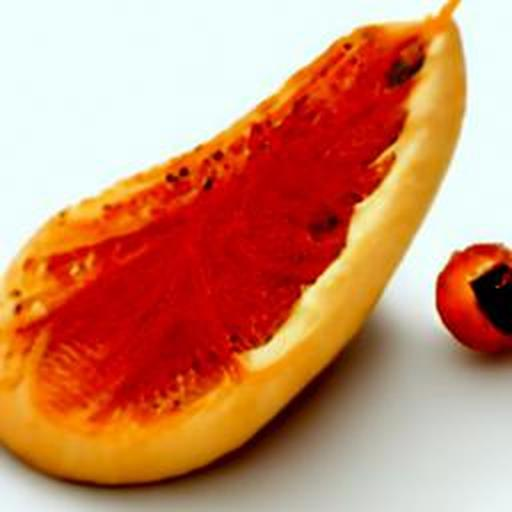Can you tell me more about the nutritional benefits of this fruit? Certainly! Papaya is rich in vitamins C and A, which are excellent for immune function and skin health, respectively. It also contains an enzyme called papain, which aids digestion, and is a good source of antioxidants and dietary fiber. 